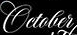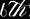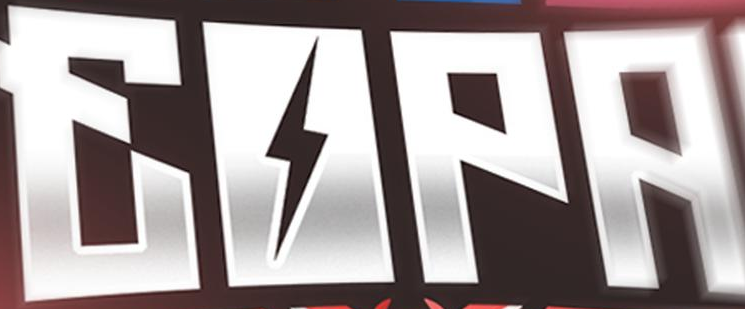Transcribe the words shown in these images in order, separated by a semicolon. October; 6th; EOPA 